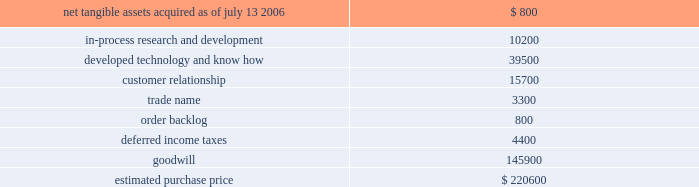Hologic , inc .
Notes to consolidated financial statements ( continued ) ( in thousands , except per share data ) determination of the measurement date for the market price of acquirer securities issued in a purchase business combination .
The components and allocation of the purchase price , consists of the following approximate amounts: .
The company has begun to assess and formulate a plan to restructure certain of r2 2019s historical activities .
As of the acquisition date the company recorded a liability of approximately $ 798 in accordance with eitf issue no .
95-3 , recognition of liabilities in connection with a purchase business combination , related to the termination of certain employees and loss related to the abandonment of certain lease space under this plan of which approximately $ 46 has been paid as of september 30 , 2006 .
The company believes this plan will be finalized within one year from the acquisition date and will record any additional liabilities at such time resulting in an increase to goodwill .
The final purchase price allocations will be completed within one year of the acquisition and any adjustments are not expected to have a material impact on the company 2019s financial position or results of operation .
As part of the purchase price allocation , all intangible assets that were a part of the acquisition were identified and valued .
It was determined that only customer relationships , trademarks and developed technology had separately identifiable values .
Customer relationships represent r2 2019s strong active customer base , dominant market position and strong partnership with several large companies .
Trademarks represent the r2 product names that the company intends to continue to use .
Developed technology represents currently marketable purchased products that the company continues to resell as well as utilize to enhance and incorporate into the company 2019s existing products .
The estimated $ 10200 of purchase price allocated to in-process research and development projects primarily related to r2s digital cad products .
The projects are expected to add direct digital algorithm capabilities as well as a new platform technology to analyze images and breast density measurement .
The project is approximately 20% ( 20 % ) complete and the company expects to spend approximately $ 3100 over the year to complete .
The deferred income tax asset relates to the tax effect of acquired net operating loss carry forwards that the company believes are realizable partially offset by acquired identifiable intangible assets , and fair value adjustments to acquired inventory as such amounts are not deductible for tax purposes .
Acquisition of suros surgical systems , inc .
On july 27 , 2006 , the company completed the acquisition of suros surgical systems , inc. , pursuant to an agreement and plan of merger dated april 17 , 2006 .
The results of operations for suros have been included in the company 2019s consolidated financial statements from the date of acquisition as part of its mammography business segment .
Suros surgical , located in indianapolis , indiana , develops , manufactures and sells minimally invasive interventional breast biopsy technology and products for biopsy , tissue removal and biopsy site marking. .
What percentage of the estimated purchase price is goodwill? 
Computations: (145900 / 220600)
Answer: 0.66138. 